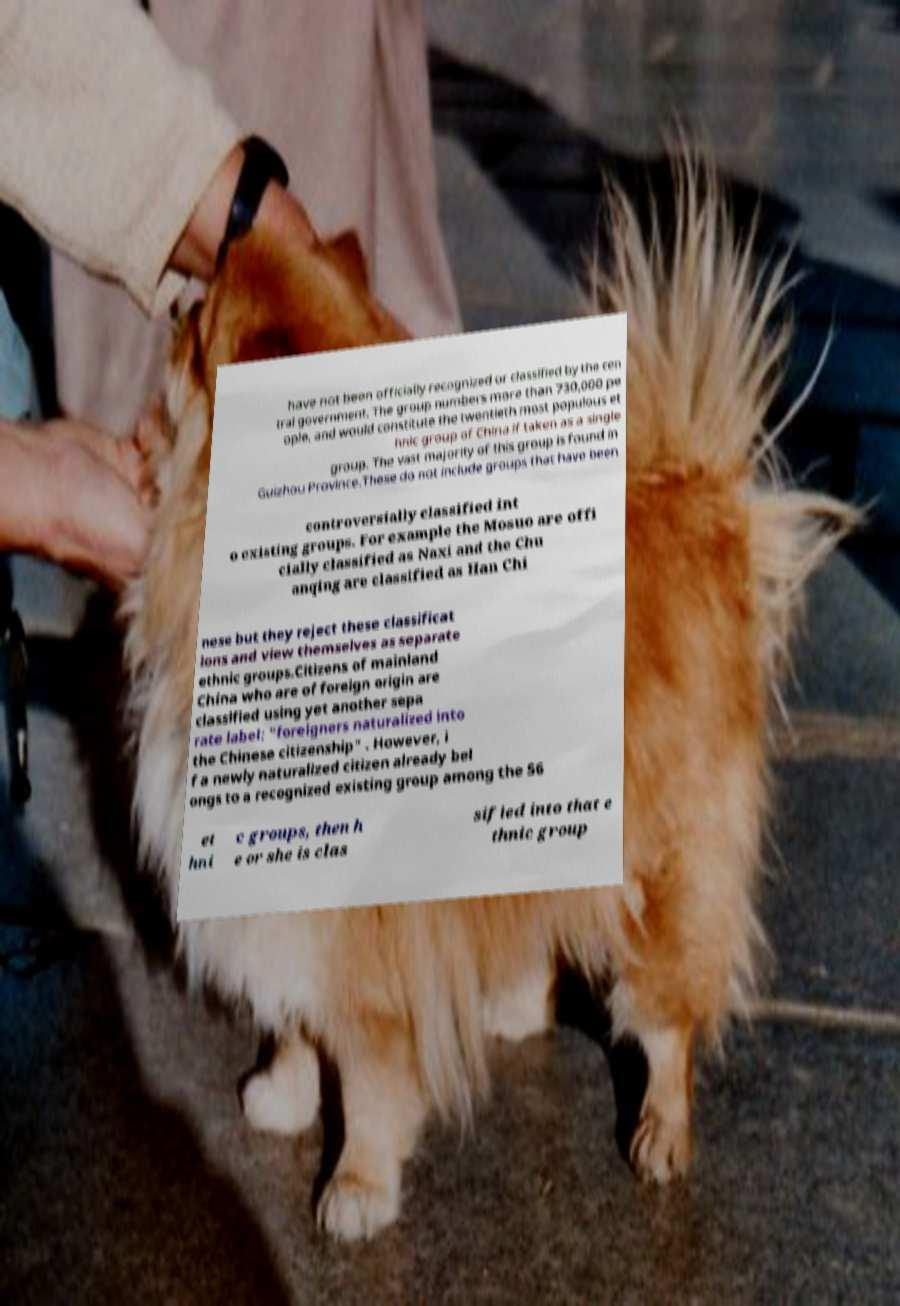I need the written content from this picture converted into text. Can you do that? have not been officially recognized or classified by the cen tral government. The group numbers more than 730,000 pe ople, and would constitute the twentieth most populous et hnic group of China if taken as a single group. The vast majority of this group is found in Guizhou Province.These do not include groups that have been controversially classified int o existing groups. For example the Mosuo are offi cially classified as Naxi and the Chu anqing are classified as Han Chi nese but they reject these classificat ions and view themselves as separate ethnic groups.Citizens of mainland China who are of foreign origin are classified using yet another sepa rate label: "foreigners naturalized into the Chinese citizenship" . However, i f a newly naturalized citizen already bel ongs to a recognized existing group among the 56 et hni c groups, then h e or she is clas sified into that e thnic group 